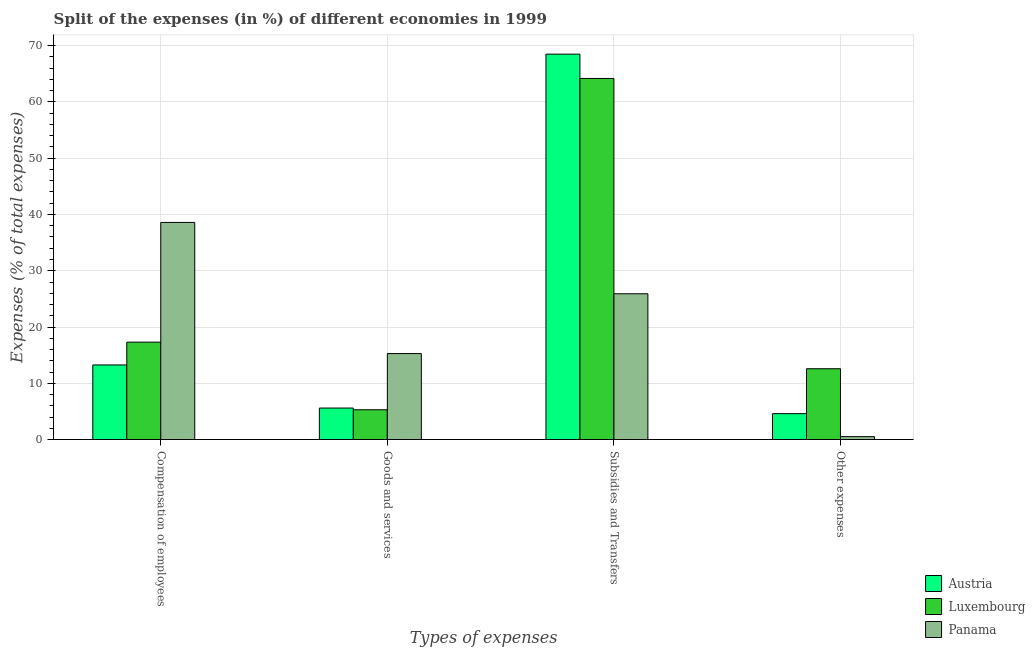How many groups of bars are there?
Your answer should be compact. 4. Are the number of bars per tick equal to the number of legend labels?
Keep it short and to the point. Yes. How many bars are there on the 2nd tick from the right?
Make the answer very short. 3. What is the label of the 3rd group of bars from the left?
Offer a very short reply. Subsidies and Transfers. What is the percentage of amount spent on goods and services in Luxembourg?
Offer a terse response. 5.3. Across all countries, what is the maximum percentage of amount spent on compensation of employees?
Provide a succinct answer. 38.58. Across all countries, what is the minimum percentage of amount spent on goods and services?
Offer a very short reply. 5.3. In which country was the percentage of amount spent on other expenses maximum?
Your answer should be compact. Luxembourg. In which country was the percentage of amount spent on goods and services minimum?
Provide a short and direct response. Luxembourg. What is the total percentage of amount spent on other expenses in the graph?
Make the answer very short. 17.73. What is the difference between the percentage of amount spent on other expenses in Panama and that in Austria?
Offer a very short reply. -4.09. What is the difference between the percentage of amount spent on goods and services in Austria and the percentage of amount spent on compensation of employees in Luxembourg?
Make the answer very short. -11.71. What is the average percentage of amount spent on compensation of employees per country?
Provide a short and direct response. 23.05. What is the difference between the percentage of amount spent on goods and services and percentage of amount spent on compensation of employees in Austria?
Give a very brief answer. -7.66. What is the ratio of the percentage of amount spent on compensation of employees in Panama to that in Luxembourg?
Your response must be concise. 2.23. Is the percentage of amount spent on other expenses in Luxembourg less than that in Austria?
Give a very brief answer. No. What is the difference between the highest and the second highest percentage of amount spent on subsidies?
Your answer should be very brief. 4.32. What is the difference between the highest and the lowest percentage of amount spent on other expenses?
Your answer should be very brief. 12.06. Is the sum of the percentage of amount spent on goods and services in Luxembourg and Panama greater than the maximum percentage of amount spent on compensation of employees across all countries?
Your answer should be very brief. No. Is it the case that in every country, the sum of the percentage of amount spent on other expenses and percentage of amount spent on goods and services is greater than the sum of percentage of amount spent on compensation of employees and percentage of amount spent on subsidies?
Give a very brief answer. No. What does the 2nd bar from the left in Subsidies and Transfers represents?
Offer a very short reply. Luxembourg. What does the 1st bar from the right in Compensation of employees represents?
Offer a terse response. Panama. Is it the case that in every country, the sum of the percentage of amount spent on compensation of employees and percentage of amount spent on goods and services is greater than the percentage of amount spent on subsidies?
Offer a very short reply. No. How many bars are there?
Offer a very short reply. 12. Does the graph contain any zero values?
Make the answer very short. No. Does the graph contain grids?
Offer a very short reply. Yes. How many legend labels are there?
Offer a terse response. 3. How are the legend labels stacked?
Offer a very short reply. Vertical. What is the title of the graph?
Provide a succinct answer. Split of the expenses (in %) of different economies in 1999. Does "Togo" appear as one of the legend labels in the graph?
Ensure brevity in your answer.  No. What is the label or title of the X-axis?
Make the answer very short. Types of expenses. What is the label or title of the Y-axis?
Make the answer very short. Expenses (% of total expenses). What is the Expenses (% of total expenses) of Austria in Compensation of employees?
Your answer should be compact. 13.26. What is the Expenses (% of total expenses) of Luxembourg in Compensation of employees?
Give a very brief answer. 17.32. What is the Expenses (% of total expenses) in Panama in Compensation of employees?
Your response must be concise. 38.58. What is the Expenses (% of total expenses) of Austria in Goods and services?
Make the answer very short. 5.61. What is the Expenses (% of total expenses) of Luxembourg in Goods and services?
Provide a succinct answer. 5.3. What is the Expenses (% of total expenses) in Panama in Goods and services?
Your answer should be very brief. 15.28. What is the Expenses (% of total expenses) of Austria in Subsidies and Transfers?
Your response must be concise. 68.48. What is the Expenses (% of total expenses) in Luxembourg in Subsidies and Transfers?
Provide a short and direct response. 64.16. What is the Expenses (% of total expenses) in Panama in Subsidies and Transfers?
Keep it short and to the point. 25.91. What is the Expenses (% of total expenses) of Austria in Other expenses?
Your response must be concise. 4.62. What is the Expenses (% of total expenses) of Luxembourg in Other expenses?
Make the answer very short. 12.59. What is the Expenses (% of total expenses) of Panama in Other expenses?
Your response must be concise. 0.53. Across all Types of expenses, what is the maximum Expenses (% of total expenses) of Austria?
Provide a succinct answer. 68.48. Across all Types of expenses, what is the maximum Expenses (% of total expenses) of Luxembourg?
Offer a terse response. 64.16. Across all Types of expenses, what is the maximum Expenses (% of total expenses) in Panama?
Your answer should be very brief. 38.58. Across all Types of expenses, what is the minimum Expenses (% of total expenses) in Austria?
Make the answer very short. 4.62. Across all Types of expenses, what is the minimum Expenses (% of total expenses) in Luxembourg?
Make the answer very short. 5.3. Across all Types of expenses, what is the minimum Expenses (% of total expenses) in Panama?
Ensure brevity in your answer.  0.53. What is the total Expenses (% of total expenses) in Austria in the graph?
Ensure brevity in your answer.  91.97. What is the total Expenses (% of total expenses) in Luxembourg in the graph?
Offer a very short reply. 99.37. What is the total Expenses (% of total expenses) of Panama in the graph?
Offer a terse response. 80.31. What is the difference between the Expenses (% of total expenses) of Austria in Compensation of employees and that in Goods and services?
Your response must be concise. 7.66. What is the difference between the Expenses (% of total expenses) in Luxembourg in Compensation of employees and that in Goods and services?
Your answer should be compact. 12.02. What is the difference between the Expenses (% of total expenses) of Panama in Compensation of employees and that in Goods and services?
Your answer should be very brief. 23.3. What is the difference between the Expenses (% of total expenses) of Austria in Compensation of employees and that in Subsidies and Transfers?
Provide a succinct answer. -55.22. What is the difference between the Expenses (% of total expenses) in Luxembourg in Compensation of employees and that in Subsidies and Transfers?
Keep it short and to the point. -46.85. What is the difference between the Expenses (% of total expenses) of Panama in Compensation of employees and that in Subsidies and Transfers?
Make the answer very short. 12.67. What is the difference between the Expenses (% of total expenses) of Austria in Compensation of employees and that in Other expenses?
Offer a terse response. 8.65. What is the difference between the Expenses (% of total expenses) of Luxembourg in Compensation of employees and that in Other expenses?
Provide a succinct answer. 4.73. What is the difference between the Expenses (% of total expenses) in Panama in Compensation of employees and that in Other expenses?
Your answer should be very brief. 38.06. What is the difference between the Expenses (% of total expenses) of Austria in Goods and services and that in Subsidies and Transfers?
Your answer should be compact. -62.88. What is the difference between the Expenses (% of total expenses) in Luxembourg in Goods and services and that in Subsidies and Transfers?
Your response must be concise. -58.86. What is the difference between the Expenses (% of total expenses) of Panama in Goods and services and that in Subsidies and Transfers?
Give a very brief answer. -10.63. What is the difference between the Expenses (% of total expenses) in Luxembourg in Goods and services and that in Other expenses?
Your answer should be very brief. -7.29. What is the difference between the Expenses (% of total expenses) in Panama in Goods and services and that in Other expenses?
Make the answer very short. 14.76. What is the difference between the Expenses (% of total expenses) in Austria in Subsidies and Transfers and that in Other expenses?
Offer a very short reply. 63.87. What is the difference between the Expenses (% of total expenses) of Luxembourg in Subsidies and Transfers and that in Other expenses?
Your answer should be compact. 51.57. What is the difference between the Expenses (% of total expenses) in Panama in Subsidies and Transfers and that in Other expenses?
Offer a very short reply. 25.38. What is the difference between the Expenses (% of total expenses) of Austria in Compensation of employees and the Expenses (% of total expenses) of Luxembourg in Goods and services?
Your answer should be very brief. 7.96. What is the difference between the Expenses (% of total expenses) of Austria in Compensation of employees and the Expenses (% of total expenses) of Panama in Goods and services?
Your answer should be compact. -2.02. What is the difference between the Expenses (% of total expenses) in Luxembourg in Compensation of employees and the Expenses (% of total expenses) in Panama in Goods and services?
Provide a succinct answer. 2.03. What is the difference between the Expenses (% of total expenses) of Austria in Compensation of employees and the Expenses (% of total expenses) of Luxembourg in Subsidies and Transfers?
Your answer should be very brief. -50.9. What is the difference between the Expenses (% of total expenses) in Austria in Compensation of employees and the Expenses (% of total expenses) in Panama in Subsidies and Transfers?
Your answer should be compact. -12.65. What is the difference between the Expenses (% of total expenses) of Luxembourg in Compensation of employees and the Expenses (% of total expenses) of Panama in Subsidies and Transfers?
Your response must be concise. -8.6. What is the difference between the Expenses (% of total expenses) of Austria in Compensation of employees and the Expenses (% of total expenses) of Luxembourg in Other expenses?
Provide a succinct answer. 0.68. What is the difference between the Expenses (% of total expenses) in Austria in Compensation of employees and the Expenses (% of total expenses) in Panama in Other expenses?
Your answer should be compact. 12.74. What is the difference between the Expenses (% of total expenses) in Luxembourg in Compensation of employees and the Expenses (% of total expenses) in Panama in Other expenses?
Offer a very short reply. 16.79. What is the difference between the Expenses (% of total expenses) in Austria in Goods and services and the Expenses (% of total expenses) in Luxembourg in Subsidies and Transfers?
Make the answer very short. -58.56. What is the difference between the Expenses (% of total expenses) in Austria in Goods and services and the Expenses (% of total expenses) in Panama in Subsidies and Transfers?
Your answer should be compact. -20.31. What is the difference between the Expenses (% of total expenses) in Luxembourg in Goods and services and the Expenses (% of total expenses) in Panama in Subsidies and Transfers?
Keep it short and to the point. -20.61. What is the difference between the Expenses (% of total expenses) of Austria in Goods and services and the Expenses (% of total expenses) of Luxembourg in Other expenses?
Your answer should be compact. -6.98. What is the difference between the Expenses (% of total expenses) of Austria in Goods and services and the Expenses (% of total expenses) of Panama in Other expenses?
Offer a terse response. 5.08. What is the difference between the Expenses (% of total expenses) of Luxembourg in Goods and services and the Expenses (% of total expenses) of Panama in Other expenses?
Your answer should be very brief. 4.77. What is the difference between the Expenses (% of total expenses) in Austria in Subsidies and Transfers and the Expenses (% of total expenses) in Luxembourg in Other expenses?
Make the answer very short. 55.89. What is the difference between the Expenses (% of total expenses) of Austria in Subsidies and Transfers and the Expenses (% of total expenses) of Panama in Other expenses?
Keep it short and to the point. 67.95. What is the difference between the Expenses (% of total expenses) of Luxembourg in Subsidies and Transfers and the Expenses (% of total expenses) of Panama in Other expenses?
Give a very brief answer. 63.64. What is the average Expenses (% of total expenses) in Austria per Types of expenses?
Ensure brevity in your answer.  22.99. What is the average Expenses (% of total expenses) of Luxembourg per Types of expenses?
Offer a very short reply. 24.84. What is the average Expenses (% of total expenses) of Panama per Types of expenses?
Provide a succinct answer. 20.08. What is the difference between the Expenses (% of total expenses) of Austria and Expenses (% of total expenses) of Luxembourg in Compensation of employees?
Offer a very short reply. -4.05. What is the difference between the Expenses (% of total expenses) in Austria and Expenses (% of total expenses) in Panama in Compensation of employees?
Make the answer very short. -25.32. What is the difference between the Expenses (% of total expenses) in Luxembourg and Expenses (% of total expenses) in Panama in Compensation of employees?
Your answer should be very brief. -21.27. What is the difference between the Expenses (% of total expenses) in Austria and Expenses (% of total expenses) in Luxembourg in Goods and services?
Ensure brevity in your answer.  0.31. What is the difference between the Expenses (% of total expenses) of Austria and Expenses (% of total expenses) of Panama in Goods and services?
Your response must be concise. -9.68. What is the difference between the Expenses (% of total expenses) of Luxembourg and Expenses (% of total expenses) of Panama in Goods and services?
Offer a terse response. -9.98. What is the difference between the Expenses (% of total expenses) in Austria and Expenses (% of total expenses) in Luxembourg in Subsidies and Transfers?
Keep it short and to the point. 4.32. What is the difference between the Expenses (% of total expenses) in Austria and Expenses (% of total expenses) in Panama in Subsidies and Transfers?
Ensure brevity in your answer.  42.57. What is the difference between the Expenses (% of total expenses) in Luxembourg and Expenses (% of total expenses) in Panama in Subsidies and Transfers?
Make the answer very short. 38.25. What is the difference between the Expenses (% of total expenses) in Austria and Expenses (% of total expenses) in Luxembourg in Other expenses?
Offer a terse response. -7.97. What is the difference between the Expenses (% of total expenses) of Austria and Expenses (% of total expenses) of Panama in Other expenses?
Your answer should be very brief. 4.09. What is the difference between the Expenses (% of total expenses) of Luxembourg and Expenses (% of total expenses) of Panama in Other expenses?
Your answer should be very brief. 12.06. What is the ratio of the Expenses (% of total expenses) of Austria in Compensation of employees to that in Goods and services?
Provide a succinct answer. 2.37. What is the ratio of the Expenses (% of total expenses) of Luxembourg in Compensation of employees to that in Goods and services?
Your answer should be very brief. 3.27. What is the ratio of the Expenses (% of total expenses) in Panama in Compensation of employees to that in Goods and services?
Provide a short and direct response. 2.52. What is the ratio of the Expenses (% of total expenses) in Austria in Compensation of employees to that in Subsidies and Transfers?
Offer a terse response. 0.19. What is the ratio of the Expenses (% of total expenses) of Luxembourg in Compensation of employees to that in Subsidies and Transfers?
Offer a very short reply. 0.27. What is the ratio of the Expenses (% of total expenses) of Panama in Compensation of employees to that in Subsidies and Transfers?
Offer a terse response. 1.49. What is the ratio of the Expenses (% of total expenses) in Austria in Compensation of employees to that in Other expenses?
Your answer should be compact. 2.87. What is the ratio of the Expenses (% of total expenses) of Luxembourg in Compensation of employees to that in Other expenses?
Your response must be concise. 1.38. What is the ratio of the Expenses (% of total expenses) of Panama in Compensation of employees to that in Other expenses?
Ensure brevity in your answer.  73.05. What is the ratio of the Expenses (% of total expenses) in Austria in Goods and services to that in Subsidies and Transfers?
Give a very brief answer. 0.08. What is the ratio of the Expenses (% of total expenses) in Luxembourg in Goods and services to that in Subsidies and Transfers?
Make the answer very short. 0.08. What is the ratio of the Expenses (% of total expenses) of Panama in Goods and services to that in Subsidies and Transfers?
Your answer should be compact. 0.59. What is the ratio of the Expenses (% of total expenses) of Austria in Goods and services to that in Other expenses?
Your answer should be very brief. 1.21. What is the ratio of the Expenses (% of total expenses) in Luxembourg in Goods and services to that in Other expenses?
Your response must be concise. 0.42. What is the ratio of the Expenses (% of total expenses) in Panama in Goods and services to that in Other expenses?
Provide a succinct answer. 28.94. What is the ratio of the Expenses (% of total expenses) of Austria in Subsidies and Transfers to that in Other expenses?
Your response must be concise. 14.84. What is the ratio of the Expenses (% of total expenses) in Luxembourg in Subsidies and Transfers to that in Other expenses?
Provide a succinct answer. 5.1. What is the ratio of the Expenses (% of total expenses) of Panama in Subsidies and Transfers to that in Other expenses?
Offer a terse response. 49.06. What is the difference between the highest and the second highest Expenses (% of total expenses) in Austria?
Provide a short and direct response. 55.22. What is the difference between the highest and the second highest Expenses (% of total expenses) of Luxembourg?
Provide a short and direct response. 46.85. What is the difference between the highest and the second highest Expenses (% of total expenses) of Panama?
Offer a terse response. 12.67. What is the difference between the highest and the lowest Expenses (% of total expenses) in Austria?
Give a very brief answer. 63.87. What is the difference between the highest and the lowest Expenses (% of total expenses) in Luxembourg?
Provide a short and direct response. 58.86. What is the difference between the highest and the lowest Expenses (% of total expenses) in Panama?
Offer a very short reply. 38.06. 